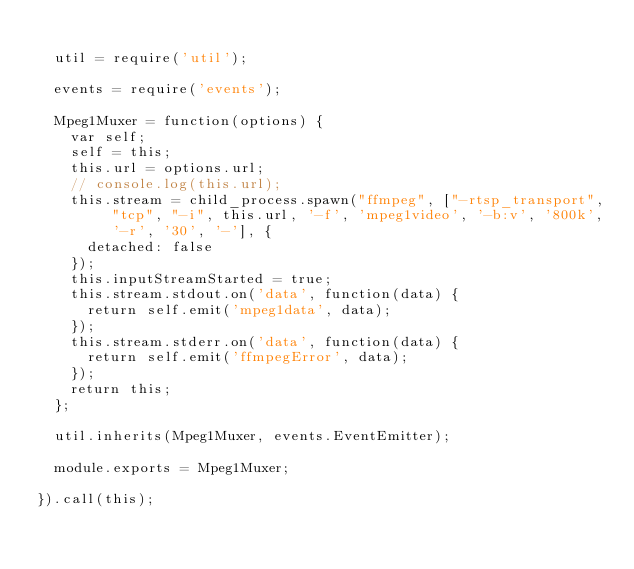<code> <loc_0><loc_0><loc_500><loc_500><_JavaScript_>
  util = require('util');

  events = require('events');

  Mpeg1Muxer = function(options) {
    var self;
    self = this;
    this.url = options.url;
    // console.log(this.url);
    this.stream = child_process.spawn("ffmpeg", ["-rtsp_transport", "tcp", "-i", this.url, '-f', 'mpeg1video', '-b:v', '800k', '-r', '30', '-'], {
      detached: false
    });
    this.inputStreamStarted = true;
    this.stream.stdout.on('data', function(data) {
      return self.emit('mpeg1data', data);
    });
    this.stream.stderr.on('data', function(data) {
      return self.emit('ffmpegError', data);
    });
    return this;
  };

  util.inherits(Mpeg1Muxer, events.EventEmitter);

  module.exports = Mpeg1Muxer;

}).call(this);
</code> 